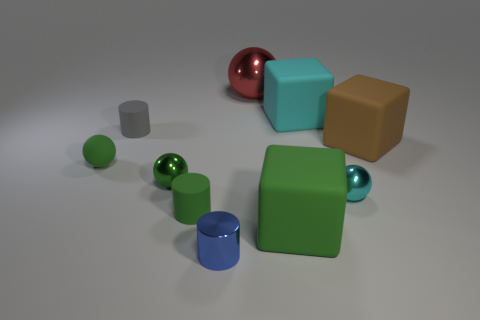Subtract all green metal balls. How many balls are left? 3 Subtract all green cylinders. How many cylinders are left? 2 Subtract all green cylinders. How many green spheres are left? 2 Subtract all cylinders. How many objects are left? 7 Subtract 2 balls. How many balls are left? 2 Subtract all gray cylinders. Subtract all gray blocks. How many cylinders are left? 2 Subtract all matte balls. Subtract all green matte cylinders. How many objects are left? 8 Add 4 large green matte things. How many large green matte things are left? 5 Add 1 tiny brown shiny cylinders. How many tiny brown shiny cylinders exist? 1 Subtract 1 brown cubes. How many objects are left? 9 